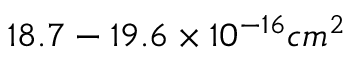<formula> <loc_0><loc_0><loc_500><loc_500>1 8 . 7 - 1 9 . 6 \times 1 0 ^ { - 1 6 } c m ^ { 2 }</formula> 